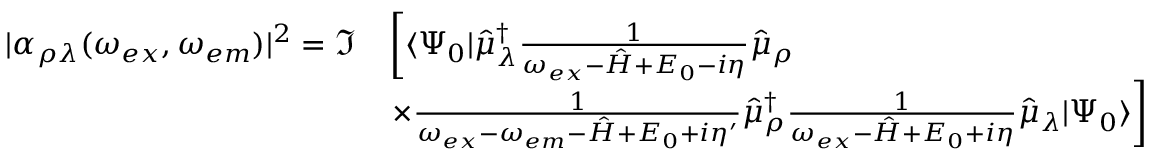<formula> <loc_0><loc_0><loc_500><loc_500>\begin{array} { r l } { | \alpha _ { \rho \lambda } ( \omega _ { e x } , \omega _ { e m } ) | ^ { 2 } = \Im } & { \left [ \langle \Psi _ { 0 } | \hat { \mu } _ { \lambda } ^ { \dagger } \frac { 1 } { \omega _ { e x } - \hat { H } + E _ { 0 } - i \eta } \hat { \mu } _ { \rho } } \\ & { \times \frac { 1 } { \omega _ { e x } - \omega _ { e m } - \hat { H } + E _ { 0 } + i \eta ^ { \prime } } \hat { \mu } _ { \rho } ^ { \dagger } \frac { 1 } { \omega _ { e x } - \hat { H } + E _ { 0 } + i \eta } \hat { \mu } _ { \lambda } | \Psi _ { 0 } \rangle \right ] } \end{array}</formula> 